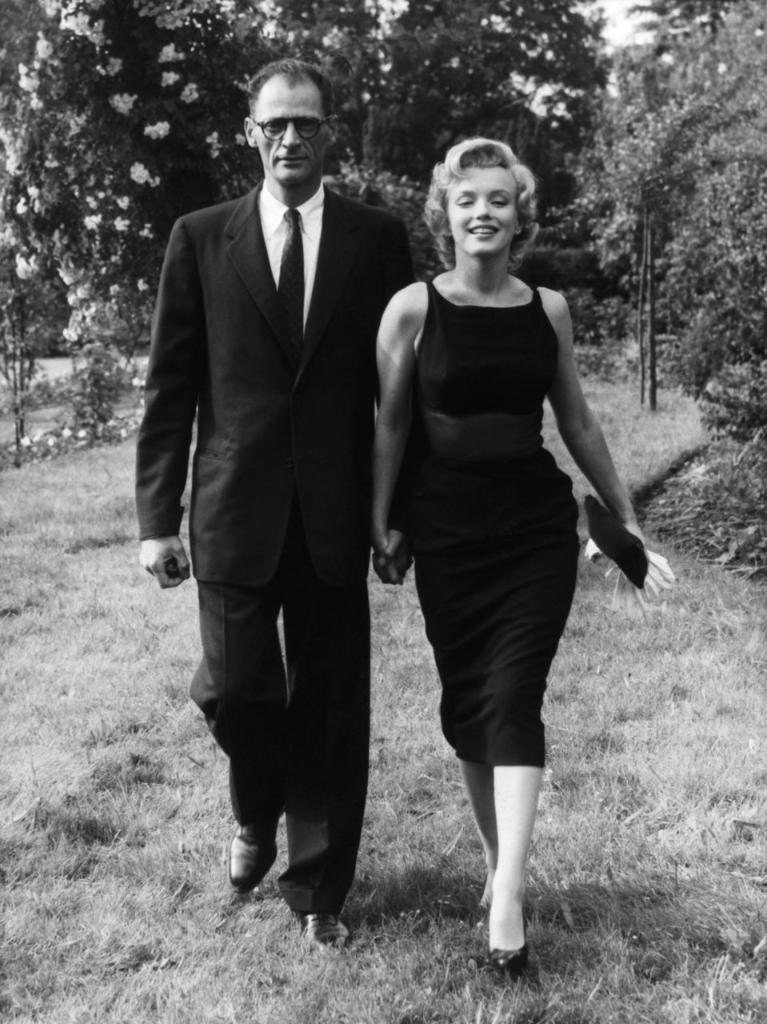What is the color scheme of the image? The image is black and white. How many people can be seen in the image? There are a few people in the image. What is visible beneath the people's feet? The ground is visible in the image. What type of vegetation is present in the image? There is grass, plants, and trees in the image. What type of carriage can be seen in the image? There is no carriage present in the image. What is the chance of finding a shade tree in the image? The image does not depict a specific location or environment, so it is impossible to determine the likelihood of finding a shade tree. 